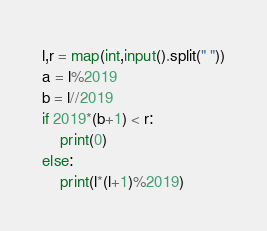Convert code to text. <code><loc_0><loc_0><loc_500><loc_500><_Python_>l,r = map(int,input().split(" "))
a = l%2019
b = l//2019
if 2019*(b+1) < r:
    print(0)
else:
    print(l*(l+1)%2019)</code> 